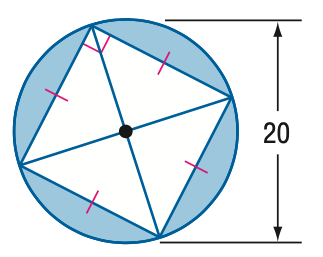Question: Find the area of the blue region.
Choices:
A. 85.8
B. 114.2
C. 214.2
D. 228.4
Answer with the letter. Answer: B 